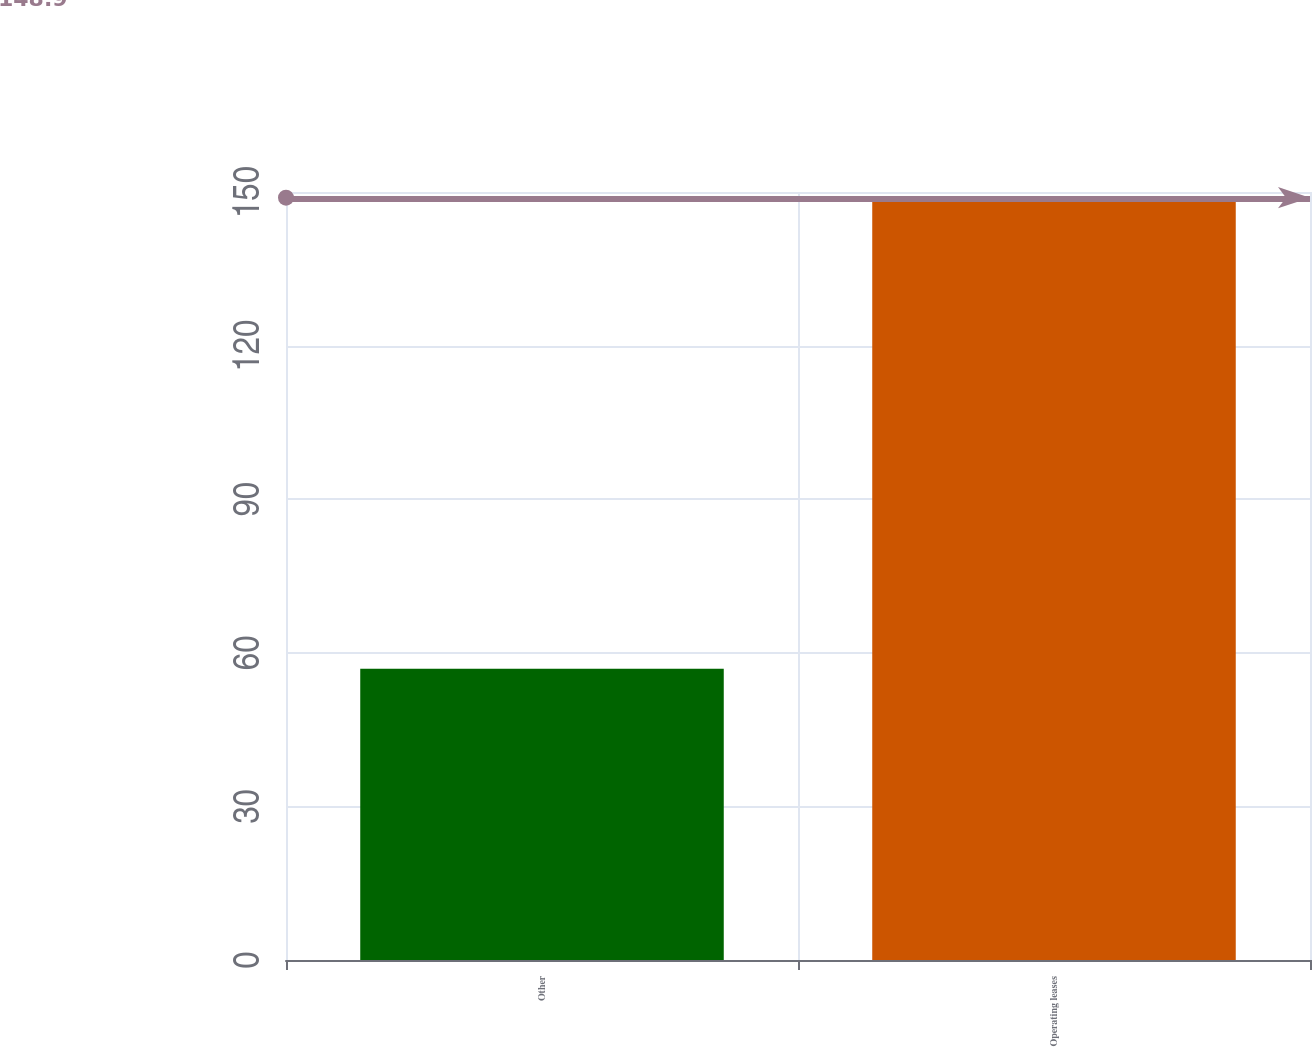<chart> <loc_0><loc_0><loc_500><loc_500><bar_chart><fcel>Other<fcel>Operating leases<nl><fcel>56.9<fcel>148.9<nl></chart> 